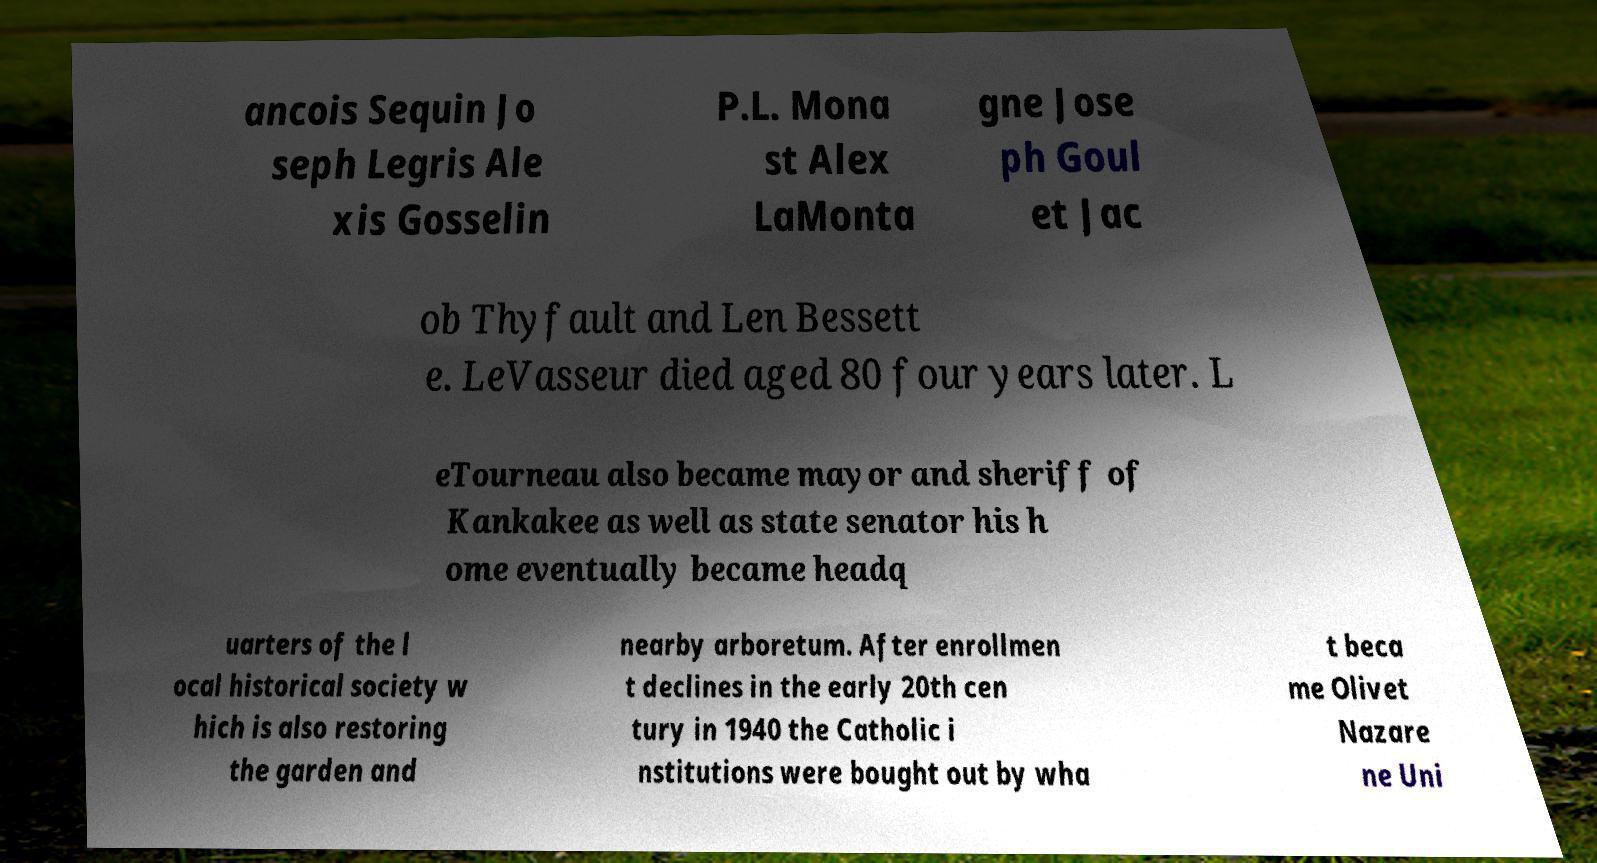Can you accurately transcribe the text from the provided image for me? ancois Sequin Jo seph Legris Ale xis Gosselin P.L. Mona st Alex LaMonta gne Jose ph Goul et Jac ob Thyfault and Len Bessett e. LeVasseur died aged 80 four years later. L eTourneau also became mayor and sheriff of Kankakee as well as state senator his h ome eventually became headq uarters of the l ocal historical society w hich is also restoring the garden and nearby arboretum. After enrollmen t declines in the early 20th cen tury in 1940 the Catholic i nstitutions were bought out by wha t beca me Olivet Nazare ne Uni 